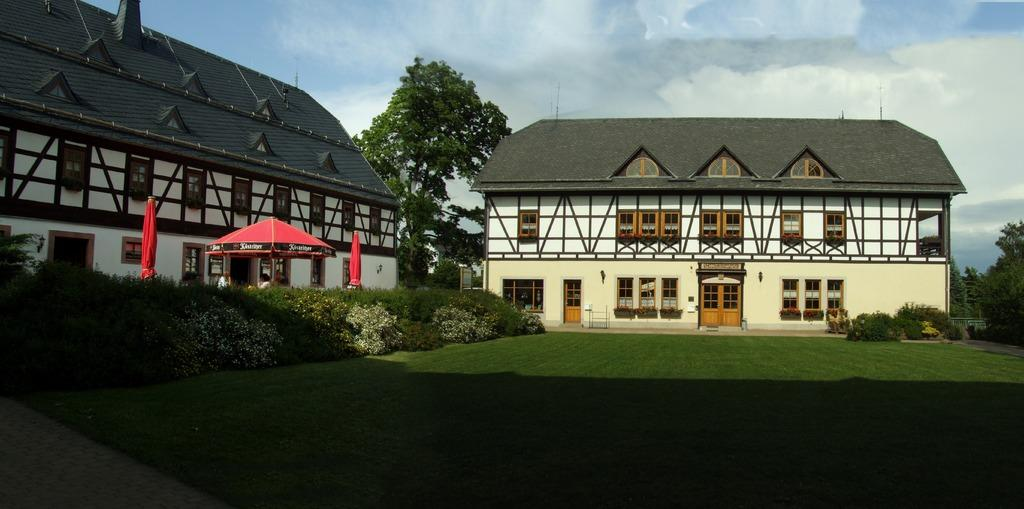How many red umbrellas can be seen in the image? There are two red umbrellas in the image. What color are the trees in the image? The trees in the image are green. What can be seen in the background of the image? There are buildings in the background of the image. What colors are visible in the sky in the image? The sky is blue and white in color. Can you see any chalk drawings on the ground in the image? There is no mention of chalk drawings in the image, so we cannot determine if they are present or not. 